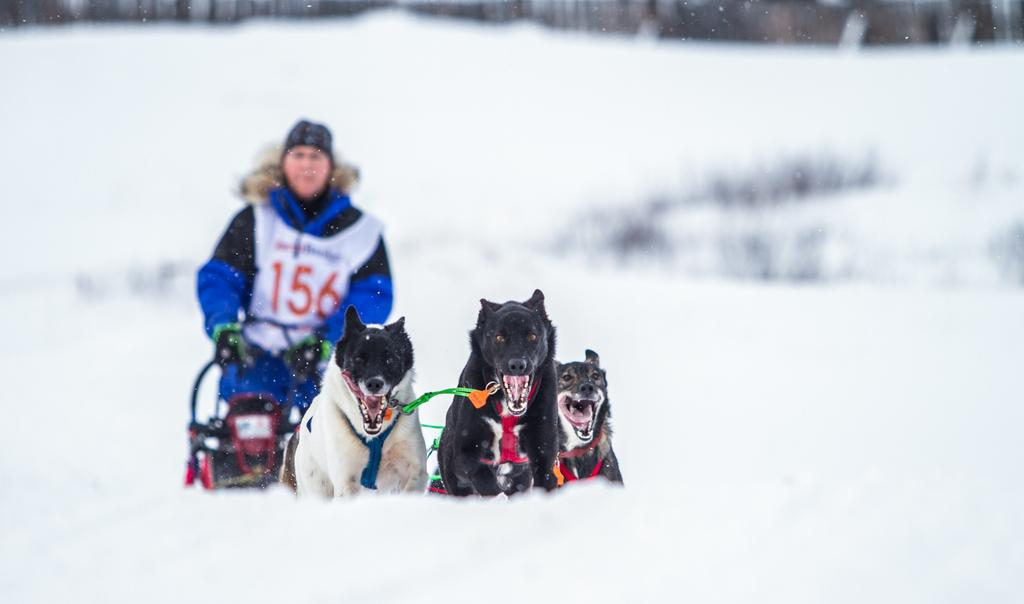What is the main subject of the image? The main subject of the image is a person standing on the snow. Are there any other living beings in the image? Yes, there are three dogs in front of the person. What type of sponge can be seen in the image? There is no sponge present in the image. Is the person wearing a scarf in the image? The provided facts do not mention anything about the person's clothing, so we cannot determine if they are wearing a scarf. 